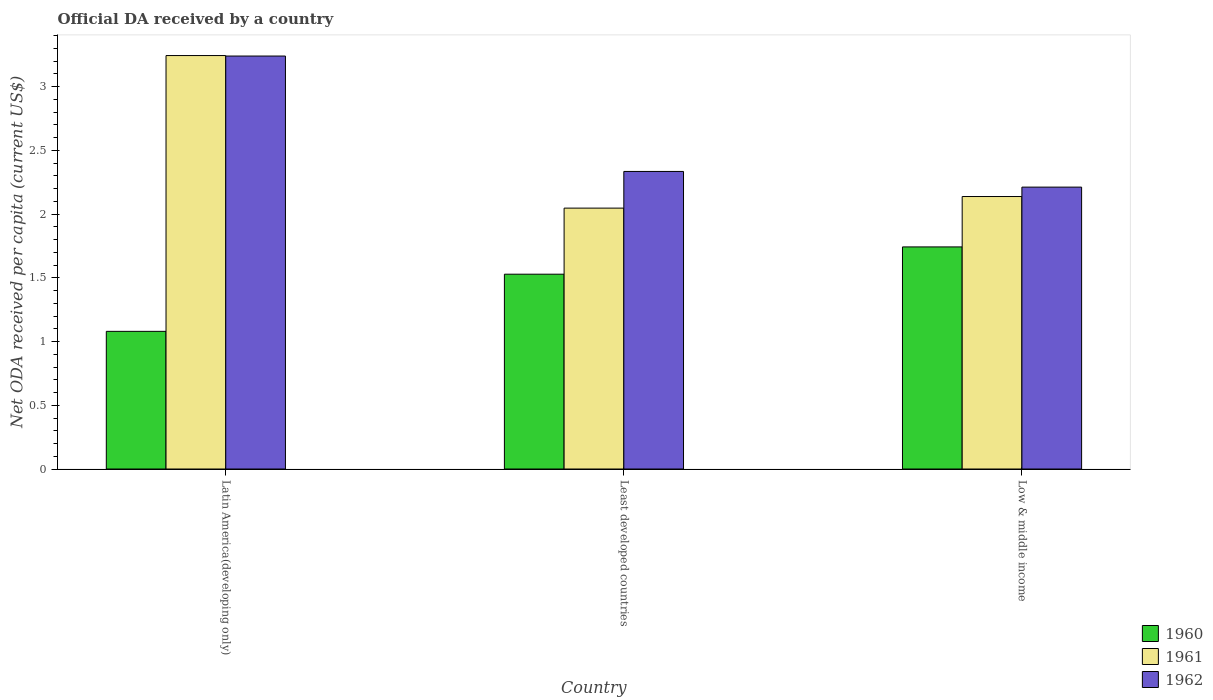How many different coloured bars are there?
Give a very brief answer. 3. Are the number of bars on each tick of the X-axis equal?
Offer a terse response. Yes. What is the label of the 1st group of bars from the left?
Your answer should be very brief. Latin America(developing only). In how many cases, is the number of bars for a given country not equal to the number of legend labels?
Your response must be concise. 0. What is the ODA received in in 1962 in Low & middle income?
Offer a very short reply. 2.21. Across all countries, what is the maximum ODA received in in 1962?
Give a very brief answer. 3.24. Across all countries, what is the minimum ODA received in in 1960?
Offer a very short reply. 1.08. In which country was the ODA received in in 1961 maximum?
Your response must be concise. Latin America(developing only). In which country was the ODA received in in 1961 minimum?
Give a very brief answer. Least developed countries. What is the total ODA received in in 1961 in the graph?
Ensure brevity in your answer.  7.43. What is the difference between the ODA received in in 1960 in Latin America(developing only) and that in Low & middle income?
Make the answer very short. -0.66. What is the difference between the ODA received in in 1960 in Least developed countries and the ODA received in in 1961 in Latin America(developing only)?
Offer a terse response. -1.72. What is the average ODA received in in 1962 per country?
Ensure brevity in your answer.  2.6. What is the difference between the ODA received in of/in 1961 and ODA received in of/in 1962 in Low & middle income?
Make the answer very short. -0.07. What is the ratio of the ODA received in in 1960 in Latin America(developing only) to that in Least developed countries?
Provide a short and direct response. 0.71. Is the ODA received in in 1960 in Latin America(developing only) less than that in Low & middle income?
Provide a succinct answer. Yes. Is the difference between the ODA received in in 1961 in Least developed countries and Low & middle income greater than the difference between the ODA received in in 1962 in Least developed countries and Low & middle income?
Your answer should be compact. No. What is the difference between the highest and the second highest ODA received in in 1960?
Offer a very short reply. 0.21. What is the difference between the highest and the lowest ODA received in in 1960?
Offer a terse response. 0.66. In how many countries, is the ODA received in in 1960 greater than the average ODA received in in 1960 taken over all countries?
Offer a terse response. 2. Is the sum of the ODA received in in 1960 in Latin America(developing only) and Low & middle income greater than the maximum ODA received in in 1962 across all countries?
Ensure brevity in your answer.  No. What does the 3rd bar from the left in Least developed countries represents?
Give a very brief answer. 1962. What does the 3rd bar from the right in Least developed countries represents?
Your answer should be very brief. 1960. How many bars are there?
Make the answer very short. 9. Are all the bars in the graph horizontal?
Keep it short and to the point. No. How many countries are there in the graph?
Your answer should be compact. 3. How are the legend labels stacked?
Keep it short and to the point. Vertical. What is the title of the graph?
Make the answer very short. Official DA received by a country. Does "1978" appear as one of the legend labels in the graph?
Your response must be concise. No. What is the label or title of the Y-axis?
Offer a very short reply. Net ODA received per capita (current US$). What is the Net ODA received per capita (current US$) in 1960 in Latin America(developing only)?
Keep it short and to the point. 1.08. What is the Net ODA received per capita (current US$) of 1961 in Latin America(developing only)?
Your answer should be very brief. 3.24. What is the Net ODA received per capita (current US$) in 1962 in Latin America(developing only)?
Offer a very short reply. 3.24. What is the Net ODA received per capita (current US$) in 1960 in Least developed countries?
Your response must be concise. 1.53. What is the Net ODA received per capita (current US$) in 1961 in Least developed countries?
Keep it short and to the point. 2.05. What is the Net ODA received per capita (current US$) in 1962 in Least developed countries?
Make the answer very short. 2.33. What is the Net ODA received per capita (current US$) of 1960 in Low & middle income?
Offer a terse response. 1.74. What is the Net ODA received per capita (current US$) of 1961 in Low & middle income?
Your answer should be very brief. 2.14. What is the Net ODA received per capita (current US$) of 1962 in Low & middle income?
Keep it short and to the point. 2.21. Across all countries, what is the maximum Net ODA received per capita (current US$) in 1960?
Give a very brief answer. 1.74. Across all countries, what is the maximum Net ODA received per capita (current US$) in 1961?
Offer a terse response. 3.24. Across all countries, what is the maximum Net ODA received per capita (current US$) in 1962?
Offer a very short reply. 3.24. Across all countries, what is the minimum Net ODA received per capita (current US$) in 1960?
Your answer should be very brief. 1.08. Across all countries, what is the minimum Net ODA received per capita (current US$) in 1961?
Your answer should be compact. 2.05. Across all countries, what is the minimum Net ODA received per capita (current US$) of 1962?
Your answer should be compact. 2.21. What is the total Net ODA received per capita (current US$) of 1960 in the graph?
Offer a very short reply. 4.35. What is the total Net ODA received per capita (current US$) of 1961 in the graph?
Keep it short and to the point. 7.43. What is the total Net ODA received per capita (current US$) in 1962 in the graph?
Offer a terse response. 7.79. What is the difference between the Net ODA received per capita (current US$) in 1960 in Latin America(developing only) and that in Least developed countries?
Offer a very short reply. -0.45. What is the difference between the Net ODA received per capita (current US$) in 1961 in Latin America(developing only) and that in Least developed countries?
Keep it short and to the point. 1.2. What is the difference between the Net ODA received per capita (current US$) of 1962 in Latin America(developing only) and that in Least developed countries?
Ensure brevity in your answer.  0.91. What is the difference between the Net ODA received per capita (current US$) in 1960 in Latin America(developing only) and that in Low & middle income?
Your answer should be compact. -0.66. What is the difference between the Net ODA received per capita (current US$) in 1961 in Latin America(developing only) and that in Low & middle income?
Offer a very short reply. 1.11. What is the difference between the Net ODA received per capita (current US$) in 1962 in Latin America(developing only) and that in Low & middle income?
Give a very brief answer. 1.03. What is the difference between the Net ODA received per capita (current US$) in 1960 in Least developed countries and that in Low & middle income?
Give a very brief answer. -0.21. What is the difference between the Net ODA received per capita (current US$) in 1961 in Least developed countries and that in Low & middle income?
Your answer should be compact. -0.09. What is the difference between the Net ODA received per capita (current US$) in 1962 in Least developed countries and that in Low & middle income?
Offer a very short reply. 0.12. What is the difference between the Net ODA received per capita (current US$) in 1960 in Latin America(developing only) and the Net ODA received per capita (current US$) in 1961 in Least developed countries?
Provide a short and direct response. -0.97. What is the difference between the Net ODA received per capita (current US$) in 1960 in Latin America(developing only) and the Net ODA received per capita (current US$) in 1962 in Least developed countries?
Offer a terse response. -1.25. What is the difference between the Net ODA received per capita (current US$) in 1961 in Latin America(developing only) and the Net ODA received per capita (current US$) in 1962 in Least developed countries?
Provide a short and direct response. 0.91. What is the difference between the Net ODA received per capita (current US$) in 1960 in Latin America(developing only) and the Net ODA received per capita (current US$) in 1961 in Low & middle income?
Your answer should be compact. -1.06. What is the difference between the Net ODA received per capita (current US$) in 1960 in Latin America(developing only) and the Net ODA received per capita (current US$) in 1962 in Low & middle income?
Give a very brief answer. -1.13. What is the difference between the Net ODA received per capita (current US$) in 1961 in Latin America(developing only) and the Net ODA received per capita (current US$) in 1962 in Low & middle income?
Provide a succinct answer. 1.03. What is the difference between the Net ODA received per capita (current US$) in 1960 in Least developed countries and the Net ODA received per capita (current US$) in 1961 in Low & middle income?
Offer a terse response. -0.61. What is the difference between the Net ODA received per capita (current US$) in 1960 in Least developed countries and the Net ODA received per capita (current US$) in 1962 in Low & middle income?
Provide a succinct answer. -0.68. What is the difference between the Net ODA received per capita (current US$) of 1961 in Least developed countries and the Net ODA received per capita (current US$) of 1962 in Low & middle income?
Keep it short and to the point. -0.16. What is the average Net ODA received per capita (current US$) in 1960 per country?
Give a very brief answer. 1.45. What is the average Net ODA received per capita (current US$) of 1961 per country?
Make the answer very short. 2.48. What is the average Net ODA received per capita (current US$) of 1962 per country?
Your response must be concise. 2.6. What is the difference between the Net ODA received per capita (current US$) in 1960 and Net ODA received per capita (current US$) in 1961 in Latin America(developing only)?
Your answer should be compact. -2.16. What is the difference between the Net ODA received per capita (current US$) of 1960 and Net ODA received per capita (current US$) of 1962 in Latin America(developing only)?
Provide a short and direct response. -2.16. What is the difference between the Net ODA received per capita (current US$) in 1961 and Net ODA received per capita (current US$) in 1962 in Latin America(developing only)?
Offer a terse response. 0. What is the difference between the Net ODA received per capita (current US$) in 1960 and Net ODA received per capita (current US$) in 1961 in Least developed countries?
Offer a very short reply. -0.52. What is the difference between the Net ODA received per capita (current US$) of 1960 and Net ODA received per capita (current US$) of 1962 in Least developed countries?
Your answer should be compact. -0.81. What is the difference between the Net ODA received per capita (current US$) of 1961 and Net ODA received per capita (current US$) of 1962 in Least developed countries?
Give a very brief answer. -0.29. What is the difference between the Net ODA received per capita (current US$) in 1960 and Net ODA received per capita (current US$) in 1961 in Low & middle income?
Offer a very short reply. -0.4. What is the difference between the Net ODA received per capita (current US$) of 1960 and Net ODA received per capita (current US$) of 1962 in Low & middle income?
Your answer should be very brief. -0.47. What is the difference between the Net ODA received per capita (current US$) of 1961 and Net ODA received per capita (current US$) of 1962 in Low & middle income?
Give a very brief answer. -0.07. What is the ratio of the Net ODA received per capita (current US$) of 1960 in Latin America(developing only) to that in Least developed countries?
Offer a very short reply. 0.71. What is the ratio of the Net ODA received per capita (current US$) in 1961 in Latin America(developing only) to that in Least developed countries?
Give a very brief answer. 1.58. What is the ratio of the Net ODA received per capita (current US$) of 1962 in Latin America(developing only) to that in Least developed countries?
Your response must be concise. 1.39. What is the ratio of the Net ODA received per capita (current US$) in 1960 in Latin America(developing only) to that in Low & middle income?
Keep it short and to the point. 0.62. What is the ratio of the Net ODA received per capita (current US$) of 1961 in Latin America(developing only) to that in Low & middle income?
Your answer should be compact. 1.52. What is the ratio of the Net ODA received per capita (current US$) of 1962 in Latin America(developing only) to that in Low & middle income?
Your answer should be compact. 1.47. What is the ratio of the Net ODA received per capita (current US$) of 1960 in Least developed countries to that in Low & middle income?
Provide a succinct answer. 0.88. What is the ratio of the Net ODA received per capita (current US$) of 1961 in Least developed countries to that in Low & middle income?
Provide a short and direct response. 0.96. What is the ratio of the Net ODA received per capita (current US$) of 1962 in Least developed countries to that in Low & middle income?
Provide a short and direct response. 1.06. What is the difference between the highest and the second highest Net ODA received per capita (current US$) in 1960?
Provide a short and direct response. 0.21. What is the difference between the highest and the second highest Net ODA received per capita (current US$) in 1961?
Make the answer very short. 1.11. What is the difference between the highest and the second highest Net ODA received per capita (current US$) in 1962?
Offer a very short reply. 0.91. What is the difference between the highest and the lowest Net ODA received per capita (current US$) of 1960?
Keep it short and to the point. 0.66. What is the difference between the highest and the lowest Net ODA received per capita (current US$) in 1961?
Your answer should be very brief. 1.2. What is the difference between the highest and the lowest Net ODA received per capita (current US$) in 1962?
Ensure brevity in your answer.  1.03. 